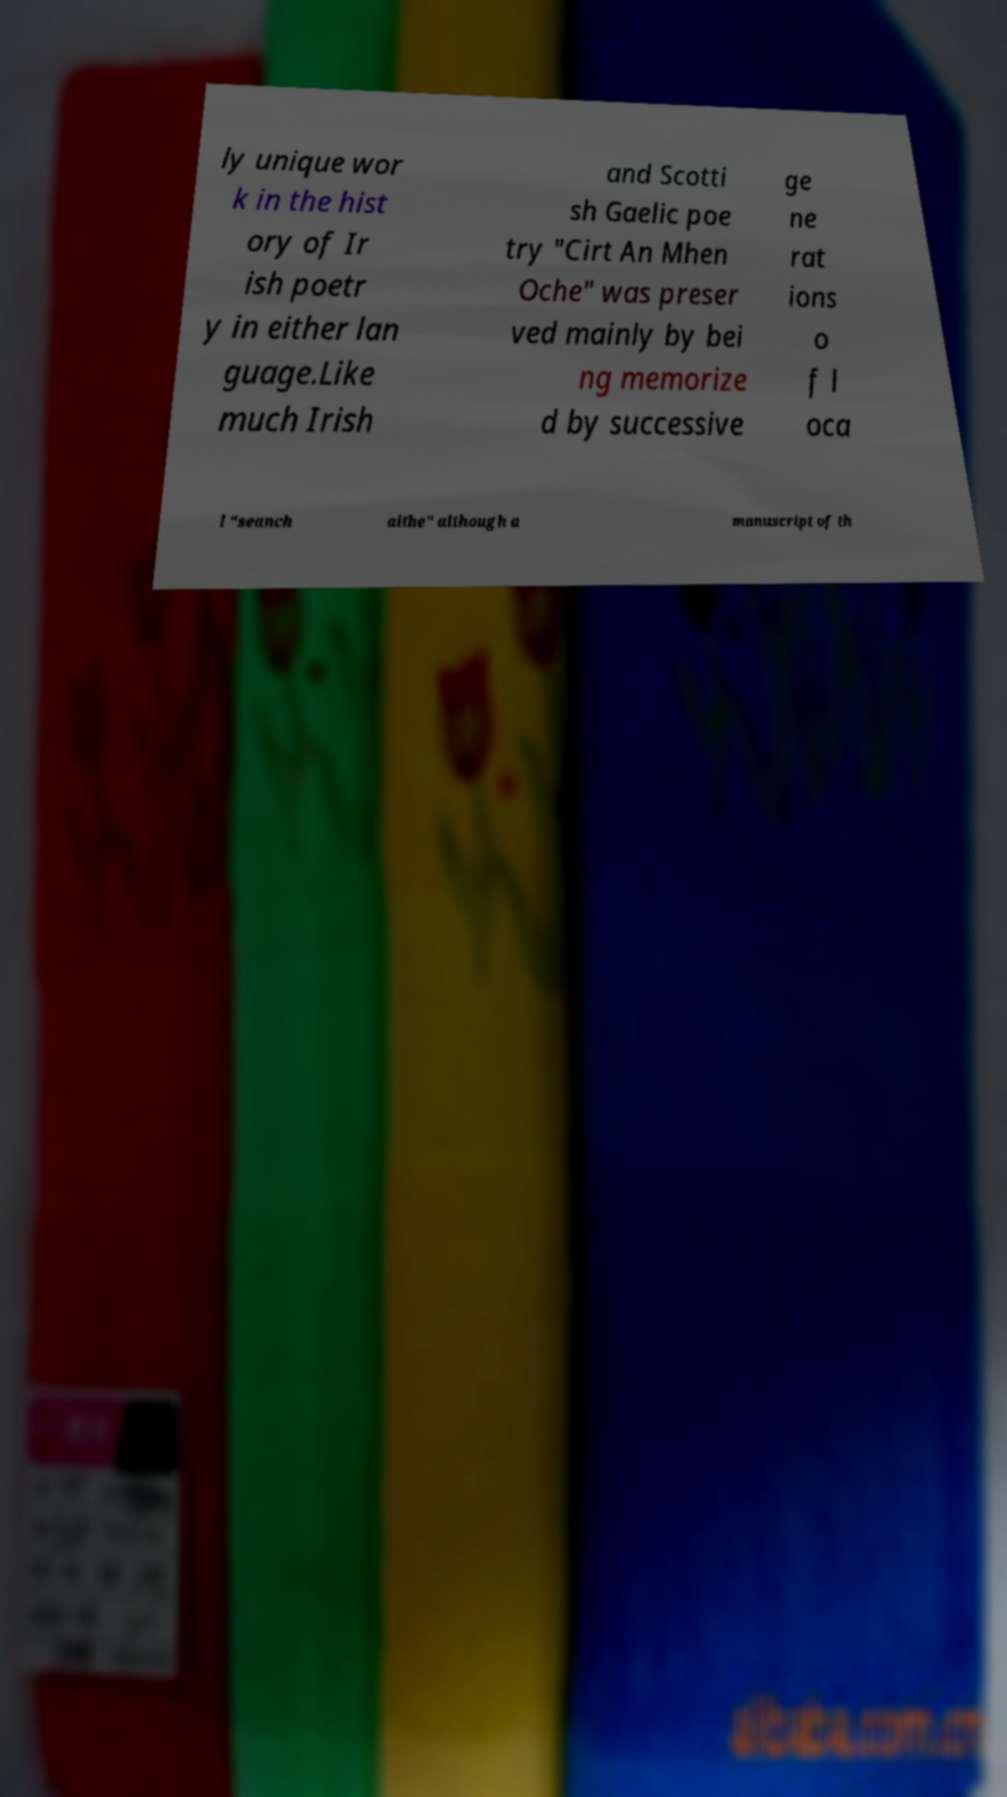For documentation purposes, I need the text within this image transcribed. Could you provide that? ly unique wor k in the hist ory of Ir ish poetr y in either lan guage.Like much Irish and Scotti sh Gaelic poe try "Cirt An Mhen Oche" was preser ved mainly by bei ng memorize d by successive ge ne rat ions o f l oca l "seanch aithe" although a manuscript of th 